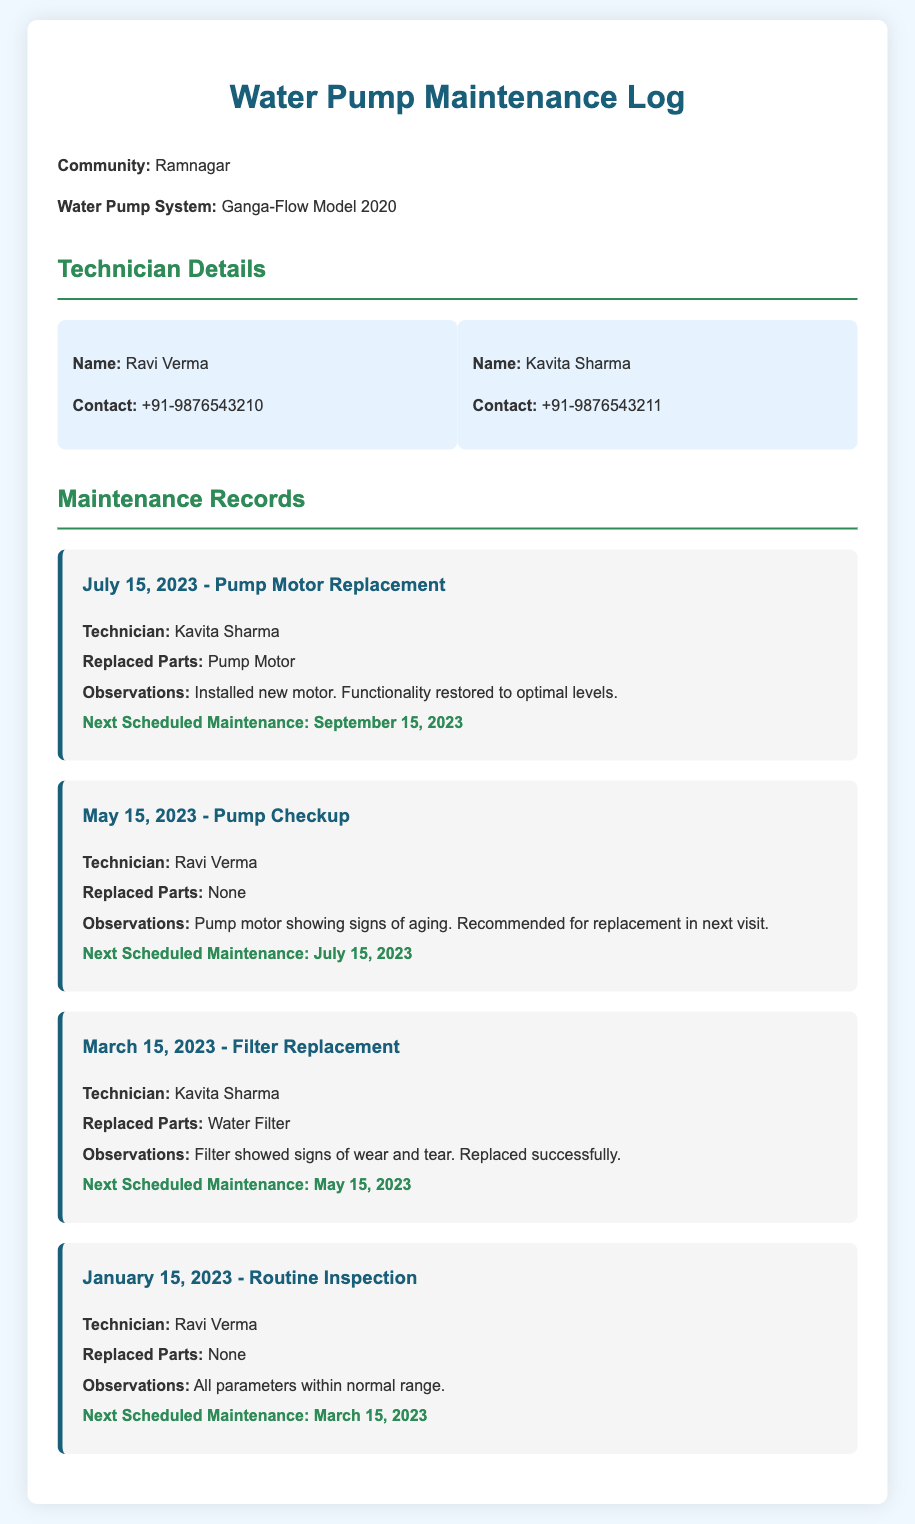what is the community's name? The community's name is mentioned at the beginning of the document.
Answer: Ramnagar who is the technician for the latest repair? The latest repair on July 15, 2023, mentions the technician's name.
Answer: Kavita Sharma what part was replaced on March 15, 2023? The specific part replaced is listed in the maintenance record for that date.
Answer: Water Filter when is the next scheduled maintenance after January 15, 2023? The next scheduled maintenance date is provided in the record following the January inspection.
Answer: March 15, 2023 how many technicians are listed? The document lists the number of technicians in the technician details section.
Answer: 2 what observation was noted during the May 15, 2023 checkup? Observations for the May 15, 2023 checkup are included in the maintenance record.
Answer: Pump motor showing signs of aging what was the observation after the last motor replacement? The observations after the motor replacement date are noted in the maintenance record.
Answer: Functionality restored to optimal levels what is the contact number for Ravi Verma? The contact details for Ravi Verma are provided under his technician card.
Answer: +91-9876543210 